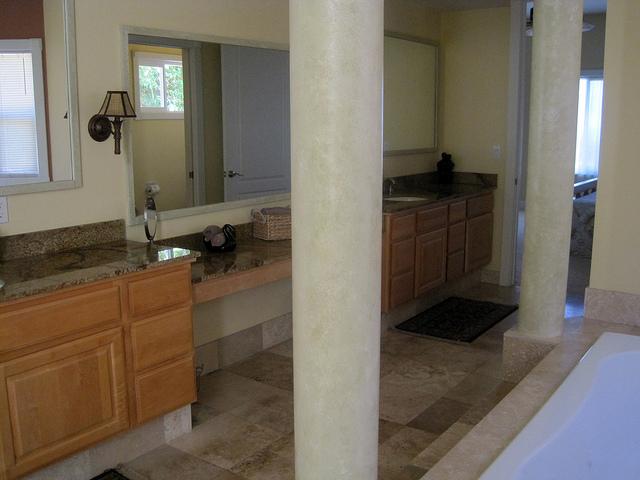How many windows are in the room?
Quick response, please. 2. What room is this?
Short answer required. Bathroom. How many pillars are there?
Keep it brief. 2. Is the ground dirty?
Short answer required. No. Is this outdoors?
Concise answer only. No. 